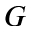<formula> <loc_0><loc_0><loc_500><loc_500>G</formula> 